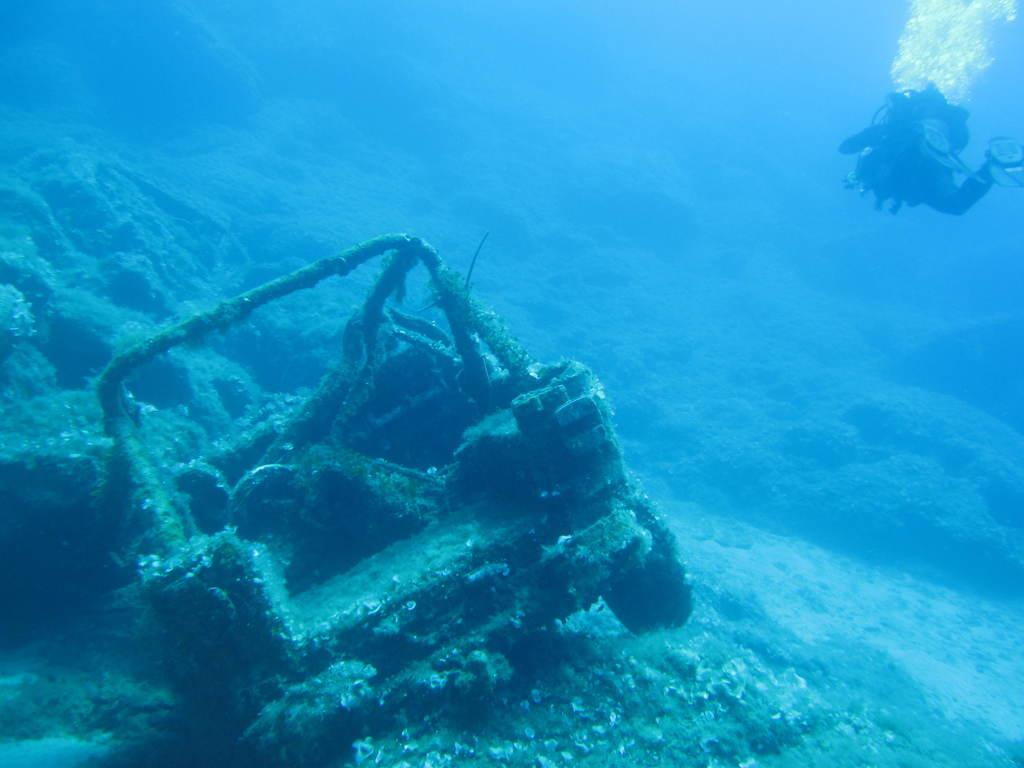What is the main subject of the image? The main subject of the image is an inside view of water. What can be seen on the left side of the image? There is a vehicle and a person on the left side of the image. What type of scent can be detected from the orange in the image? There is no orange present in the image, so no scent can be detected. 